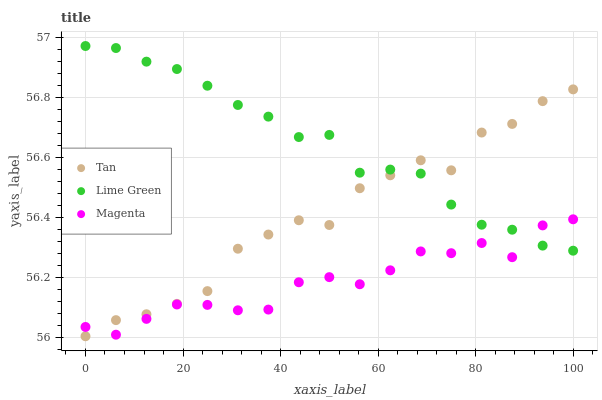Does Magenta have the minimum area under the curve?
Answer yes or no. Yes. Does Lime Green have the maximum area under the curve?
Answer yes or no. Yes. Does Lime Green have the minimum area under the curve?
Answer yes or no. No. Does Magenta have the maximum area under the curve?
Answer yes or no. No. Is Lime Green the smoothest?
Answer yes or no. Yes. Is Tan the roughest?
Answer yes or no. Yes. Is Magenta the smoothest?
Answer yes or no. No. Is Magenta the roughest?
Answer yes or no. No. Does Tan have the lowest value?
Answer yes or no. Yes. Does Magenta have the lowest value?
Answer yes or no. No. Does Lime Green have the highest value?
Answer yes or no. Yes. Does Magenta have the highest value?
Answer yes or no. No. Does Lime Green intersect Magenta?
Answer yes or no. Yes. Is Lime Green less than Magenta?
Answer yes or no. No. Is Lime Green greater than Magenta?
Answer yes or no. No. 